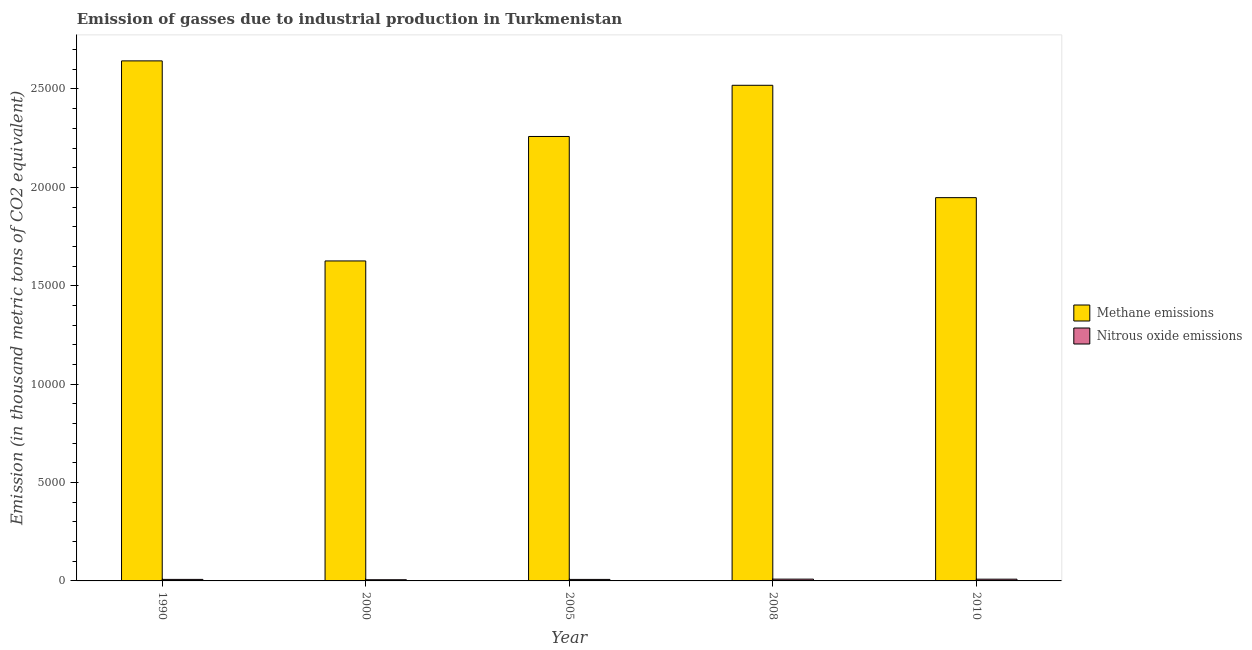How many different coloured bars are there?
Offer a very short reply. 2. What is the label of the 4th group of bars from the left?
Give a very brief answer. 2008. In how many cases, is the number of bars for a given year not equal to the number of legend labels?
Ensure brevity in your answer.  0. What is the amount of nitrous oxide emissions in 1990?
Your answer should be compact. 77.1. Across all years, what is the maximum amount of methane emissions?
Your answer should be very brief. 2.64e+04. Across all years, what is the minimum amount of methane emissions?
Keep it short and to the point. 1.63e+04. In which year was the amount of methane emissions minimum?
Keep it short and to the point. 2000. What is the total amount of nitrous oxide emissions in the graph?
Provide a short and direct response. 393.9. What is the difference between the amount of methane emissions in 2000 and that in 2005?
Your response must be concise. -6325. What is the difference between the amount of nitrous oxide emissions in 2000 and the amount of methane emissions in 2008?
Your response must be concise. -30.6. What is the average amount of methane emissions per year?
Offer a terse response. 2.20e+04. In the year 2000, what is the difference between the amount of methane emissions and amount of nitrous oxide emissions?
Offer a terse response. 0. In how many years, is the amount of nitrous oxide emissions greater than 22000 thousand metric tons?
Your response must be concise. 0. What is the ratio of the amount of nitrous oxide emissions in 1990 to that in 2000?
Offer a terse response. 1.27. Is the amount of methane emissions in 2000 less than that in 2010?
Offer a terse response. Yes. What is the difference between the highest and the second highest amount of nitrous oxide emissions?
Keep it short and to the point. 2.4. What is the difference between the highest and the lowest amount of nitrous oxide emissions?
Keep it short and to the point. 30.6. Is the sum of the amount of methane emissions in 1990 and 2008 greater than the maximum amount of nitrous oxide emissions across all years?
Give a very brief answer. Yes. What does the 1st bar from the left in 2008 represents?
Your answer should be compact. Methane emissions. What does the 2nd bar from the right in 2005 represents?
Make the answer very short. Methane emissions. How many years are there in the graph?
Keep it short and to the point. 5. Does the graph contain grids?
Give a very brief answer. No. Where does the legend appear in the graph?
Keep it short and to the point. Center right. What is the title of the graph?
Offer a very short reply. Emission of gasses due to industrial production in Turkmenistan. What is the label or title of the Y-axis?
Provide a succinct answer. Emission (in thousand metric tons of CO2 equivalent). What is the Emission (in thousand metric tons of CO2 equivalent) in Methane emissions in 1990?
Give a very brief answer. 2.64e+04. What is the Emission (in thousand metric tons of CO2 equivalent) of Nitrous oxide emissions in 1990?
Ensure brevity in your answer.  77.1. What is the Emission (in thousand metric tons of CO2 equivalent) in Methane emissions in 2000?
Make the answer very short. 1.63e+04. What is the Emission (in thousand metric tons of CO2 equivalent) in Nitrous oxide emissions in 2000?
Give a very brief answer. 60.5. What is the Emission (in thousand metric tons of CO2 equivalent) of Methane emissions in 2005?
Your answer should be very brief. 2.26e+04. What is the Emission (in thousand metric tons of CO2 equivalent) of Nitrous oxide emissions in 2005?
Offer a very short reply. 76.5. What is the Emission (in thousand metric tons of CO2 equivalent) in Methane emissions in 2008?
Keep it short and to the point. 2.52e+04. What is the Emission (in thousand metric tons of CO2 equivalent) in Nitrous oxide emissions in 2008?
Ensure brevity in your answer.  91.1. What is the Emission (in thousand metric tons of CO2 equivalent) of Methane emissions in 2010?
Keep it short and to the point. 1.95e+04. What is the Emission (in thousand metric tons of CO2 equivalent) in Nitrous oxide emissions in 2010?
Your answer should be compact. 88.7. Across all years, what is the maximum Emission (in thousand metric tons of CO2 equivalent) of Methane emissions?
Your response must be concise. 2.64e+04. Across all years, what is the maximum Emission (in thousand metric tons of CO2 equivalent) of Nitrous oxide emissions?
Your answer should be compact. 91.1. Across all years, what is the minimum Emission (in thousand metric tons of CO2 equivalent) of Methane emissions?
Your answer should be compact. 1.63e+04. Across all years, what is the minimum Emission (in thousand metric tons of CO2 equivalent) of Nitrous oxide emissions?
Make the answer very short. 60.5. What is the total Emission (in thousand metric tons of CO2 equivalent) of Methane emissions in the graph?
Your answer should be very brief. 1.10e+05. What is the total Emission (in thousand metric tons of CO2 equivalent) of Nitrous oxide emissions in the graph?
Offer a very short reply. 393.9. What is the difference between the Emission (in thousand metric tons of CO2 equivalent) in Methane emissions in 1990 and that in 2000?
Your answer should be compact. 1.02e+04. What is the difference between the Emission (in thousand metric tons of CO2 equivalent) in Methane emissions in 1990 and that in 2005?
Your answer should be very brief. 3842.2. What is the difference between the Emission (in thousand metric tons of CO2 equivalent) of Methane emissions in 1990 and that in 2008?
Offer a very short reply. 1240.2. What is the difference between the Emission (in thousand metric tons of CO2 equivalent) of Nitrous oxide emissions in 1990 and that in 2008?
Provide a short and direct response. -14. What is the difference between the Emission (in thousand metric tons of CO2 equivalent) in Methane emissions in 1990 and that in 2010?
Provide a succinct answer. 6950.9. What is the difference between the Emission (in thousand metric tons of CO2 equivalent) of Nitrous oxide emissions in 1990 and that in 2010?
Keep it short and to the point. -11.6. What is the difference between the Emission (in thousand metric tons of CO2 equivalent) of Methane emissions in 2000 and that in 2005?
Your answer should be very brief. -6325. What is the difference between the Emission (in thousand metric tons of CO2 equivalent) of Methane emissions in 2000 and that in 2008?
Your answer should be very brief. -8927. What is the difference between the Emission (in thousand metric tons of CO2 equivalent) of Nitrous oxide emissions in 2000 and that in 2008?
Offer a very short reply. -30.6. What is the difference between the Emission (in thousand metric tons of CO2 equivalent) of Methane emissions in 2000 and that in 2010?
Keep it short and to the point. -3216.3. What is the difference between the Emission (in thousand metric tons of CO2 equivalent) in Nitrous oxide emissions in 2000 and that in 2010?
Keep it short and to the point. -28.2. What is the difference between the Emission (in thousand metric tons of CO2 equivalent) in Methane emissions in 2005 and that in 2008?
Your answer should be compact. -2602. What is the difference between the Emission (in thousand metric tons of CO2 equivalent) in Nitrous oxide emissions in 2005 and that in 2008?
Ensure brevity in your answer.  -14.6. What is the difference between the Emission (in thousand metric tons of CO2 equivalent) in Methane emissions in 2005 and that in 2010?
Give a very brief answer. 3108.7. What is the difference between the Emission (in thousand metric tons of CO2 equivalent) in Nitrous oxide emissions in 2005 and that in 2010?
Ensure brevity in your answer.  -12.2. What is the difference between the Emission (in thousand metric tons of CO2 equivalent) of Methane emissions in 2008 and that in 2010?
Your response must be concise. 5710.7. What is the difference between the Emission (in thousand metric tons of CO2 equivalent) of Methane emissions in 1990 and the Emission (in thousand metric tons of CO2 equivalent) of Nitrous oxide emissions in 2000?
Keep it short and to the point. 2.64e+04. What is the difference between the Emission (in thousand metric tons of CO2 equivalent) of Methane emissions in 1990 and the Emission (in thousand metric tons of CO2 equivalent) of Nitrous oxide emissions in 2005?
Make the answer very short. 2.64e+04. What is the difference between the Emission (in thousand metric tons of CO2 equivalent) of Methane emissions in 1990 and the Emission (in thousand metric tons of CO2 equivalent) of Nitrous oxide emissions in 2008?
Offer a very short reply. 2.63e+04. What is the difference between the Emission (in thousand metric tons of CO2 equivalent) in Methane emissions in 1990 and the Emission (in thousand metric tons of CO2 equivalent) in Nitrous oxide emissions in 2010?
Give a very brief answer. 2.63e+04. What is the difference between the Emission (in thousand metric tons of CO2 equivalent) in Methane emissions in 2000 and the Emission (in thousand metric tons of CO2 equivalent) in Nitrous oxide emissions in 2005?
Offer a terse response. 1.62e+04. What is the difference between the Emission (in thousand metric tons of CO2 equivalent) of Methane emissions in 2000 and the Emission (in thousand metric tons of CO2 equivalent) of Nitrous oxide emissions in 2008?
Offer a terse response. 1.62e+04. What is the difference between the Emission (in thousand metric tons of CO2 equivalent) in Methane emissions in 2000 and the Emission (in thousand metric tons of CO2 equivalent) in Nitrous oxide emissions in 2010?
Ensure brevity in your answer.  1.62e+04. What is the difference between the Emission (in thousand metric tons of CO2 equivalent) of Methane emissions in 2005 and the Emission (in thousand metric tons of CO2 equivalent) of Nitrous oxide emissions in 2008?
Your answer should be very brief. 2.25e+04. What is the difference between the Emission (in thousand metric tons of CO2 equivalent) of Methane emissions in 2005 and the Emission (in thousand metric tons of CO2 equivalent) of Nitrous oxide emissions in 2010?
Offer a very short reply. 2.25e+04. What is the difference between the Emission (in thousand metric tons of CO2 equivalent) of Methane emissions in 2008 and the Emission (in thousand metric tons of CO2 equivalent) of Nitrous oxide emissions in 2010?
Ensure brevity in your answer.  2.51e+04. What is the average Emission (in thousand metric tons of CO2 equivalent) of Methane emissions per year?
Offer a terse response. 2.20e+04. What is the average Emission (in thousand metric tons of CO2 equivalent) in Nitrous oxide emissions per year?
Offer a very short reply. 78.78. In the year 1990, what is the difference between the Emission (in thousand metric tons of CO2 equivalent) of Methane emissions and Emission (in thousand metric tons of CO2 equivalent) of Nitrous oxide emissions?
Make the answer very short. 2.64e+04. In the year 2000, what is the difference between the Emission (in thousand metric tons of CO2 equivalent) in Methane emissions and Emission (in thousand metric tons of CO2 equivalent) in Nitrous oxide emissions?
Ensure brevity in your answer.  1.62e+04. In the year 2005, what is the difference between the Emission (in thousand metric tons of CO2 equivalent) of Methane emissions and Emission (in thousand metric tons of CO2 equivalent) of Nitrous oxide emissions?
Keep it short and to the point. 2.25e+04. In the year 2008, what is the difference between the Emission (in thousand metric tons of CO2 equivalent) of Methane emissions and Emission (in thousand metric tons of CO2 equivalent) of Nitrous oxide emissions?
Your response must be concise. 2.51e+04. In the year 2010, what is the difference between the Emission (in thousand metric tons of CO2 equivalent) in Methane emissions and Emission (in thousand metric tons of CO2 equivalent) in Nitrous oxide emissions?
Give a very brief answer. 1.94e+04. What is the ratio of the Emission (in thousand metric tons of CO2 equivalent) in Methane emissions in 1990 to that in 2000?
Your answer should be compact. 1.63. What is the ratio of the Emission (in thousand metric tons of CO2 equivalent) of Nitrous oxide emissions in 1990 to that in 2000?
Your response must be concise. 1.27. What is the ratio of the Emission (in thousand metric tons of CO2 equivalent) in Methane emissions in 1990 to that in 2005?
Give a very brief answer. 1.17. What is the ratio of the Emission (in thousand metric tons of CO2 equivalent) of Nitrous oxide emissions in 1990 to that in 2005?
Your response must be concise. 1.01. What is the ratio of the Emission (in thousand metric tons of CO2 equivalent) of Methane emissions in 1990 to that in 2008?
Your answer should be very brief. 1.05. What is the ratio of the Emission (in thousand metric tons of CO2 equivalent) of Nitrous oxide emissions in 1990 to that in 2008?
Your answer should be very brief. 0.85. What is the ratio of the Emission (in thousand metric tons of CO2 equivalent) of Methane emissions in 1990 to that in 2010?
Give a very brief answer. 1.36. What is the ratio of the Emission (in thousand metric tons of CO2 equivalent) in Nitrous oxide emissions in 1990 to that in 2010?
Keep it short and to the point. 0.87. What is the ratio of the Emission (in thousand metric tons of CO2 equivalent) in Methane emissions in 2000 to that in 2005?
Offer a terse response. 0.72. What is the ratio of the Emission (in thousand metric tons of CO2 equivalent) in Nitrous oxide emissions in 2000 to that in 2005?
Keep it short and to the point. 0.79. What is the ratio of the Emission (in thousand metric tons of CO2 equivalent) of Methane emissions in 2000 to that in 2008?
Provide a succinct answer. 0.65. What is the ratio of the Emission (in thousand metric tons of CO2 equivalent) in Nitrous oxide emissions in 2000 to that in 2008?
Keep it short and to the point. 0.66. What is the ratio of the Emission (in thousand metric tons of CO2 equivalent) of Methane emissions in 2000 to that in 2010?
Give a very brief answer. 0.83. What is the ratio of the Emission (in thousand metric tons of CO2 equivalent) in Nitrous oxide emissions in 2000 to that in 2010?
Your answer should be compact. 0.68. What is the ratio of the Emission (in thousand metric tons of CO2 equivalent) of Methane emissions in 2005 to that in 2008?
Your answer should be very brief. 0.9. What is the ratio of the Emission (in thousand metric tons of CO2 equivalent) of Nitrous oxide emissions in 2005 to that in 2008?
Keep it short and to the point. 0.84. What is the ratio of the Emission (in thousand metric tons of CO2 equivalent) of Methane emissions in 2005 to that in 2010?
Offer a terse response. 1.16. What is the ratio of the Emission (in thousand metric tons of CO2 equivalent) of Nitrous oxide emissions in 2005 to that in 2010?
Offer a terse response. 0.86. What is the ratio of the Emission (in thousand metric tons of CO2 equivalent) of Methane emissions in 2008 to that in 2010?
Your response must be concise. 1.29. What is the ratio of the Emission (in thousand metric tons of CO2 equivalent) of Nitrous oxide emissions in 2008 to that in 2010?
Your response must be concise. 1.03. What is the difference between the highest and the second highest Emission (in thousand metric tons of CO2 equivalent) of Methane emissions?
Your answer should be compact. 1240.2. What is the difference between the highest and the second highest Emission (in thousand metric tons of CO2 equivalent) in Nitrous oxide emissions?
Your answer should be compact. 2.4. What is the difference between the highest and the lowest Emission (in thousand metric tons of CO2 equivalent) of Methane emissions?
Ensure brevity in your answer.  1.02e+04. What is the difference between the highest and the lowest Emission (in thousand metric tons of CO2 equivalent) in Nitrous oxide emissions?
Give a very brief answer. 30.6. 